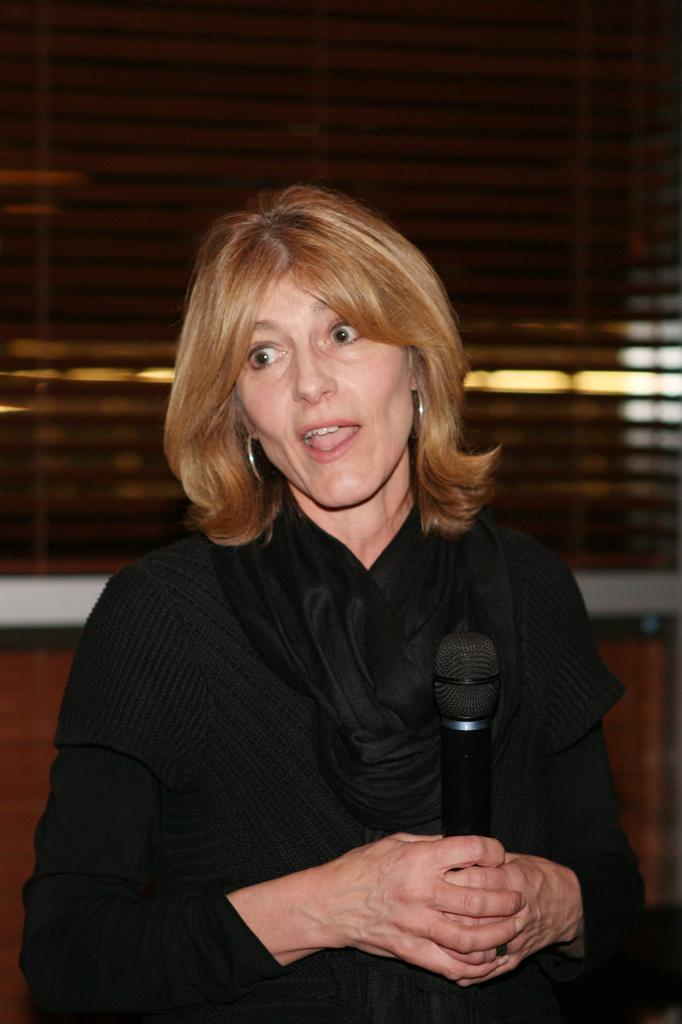Who is the main subject in the image? There is a woman in the image. What is the woman wearing? The woman is wearing a black dress. What is the woman holding in the image? The woman is holding a microphone. How many rings can be seen on the roof in the image? There is no roof or rings present in the image. What is the woman's level of fear in the image? The image does not provide any information about the woman's emotions or feelings, including fear. 